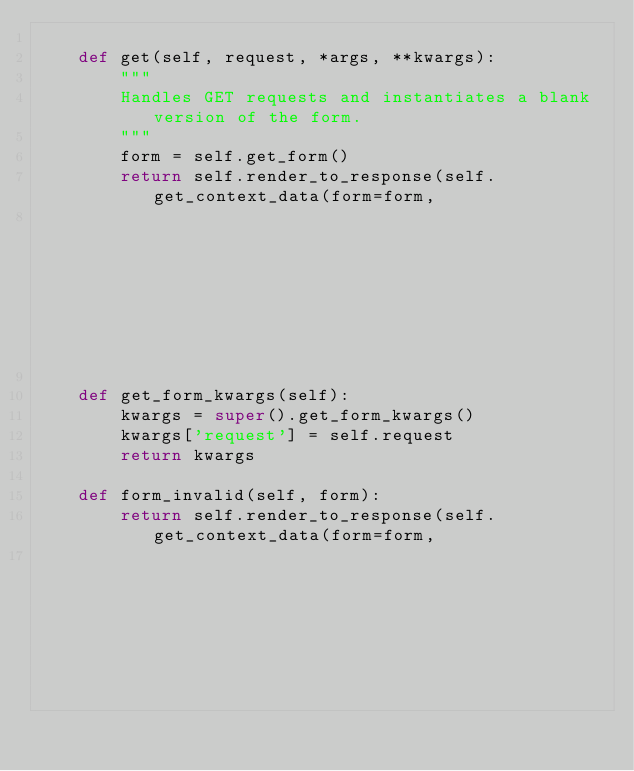Convert code to text. <code><loc_0><loc_0><loc_500><loc_500><_Python_>
    def get(self, request, *args, **kwargs):
        """
        Handles GET requests and instantiates a blank version of the form.
        """
        form = self.get_form()
        return self.render_to_response(self.get_context_data(form=form,
                                                             analyze_data_order_pk=self.analyze_data_order_pk))

    def get_form_kwargs(self):
        kwargs = super().get_form_kwargs()
        kwargs['request'] = self.request
        return kwargs

    def form_invalid(self, form):
        return self.render_to_response(self.get_context_data(form=form,
                                                             analyze_data_order_pk=self.analyze_data_order_pk))
</code> 